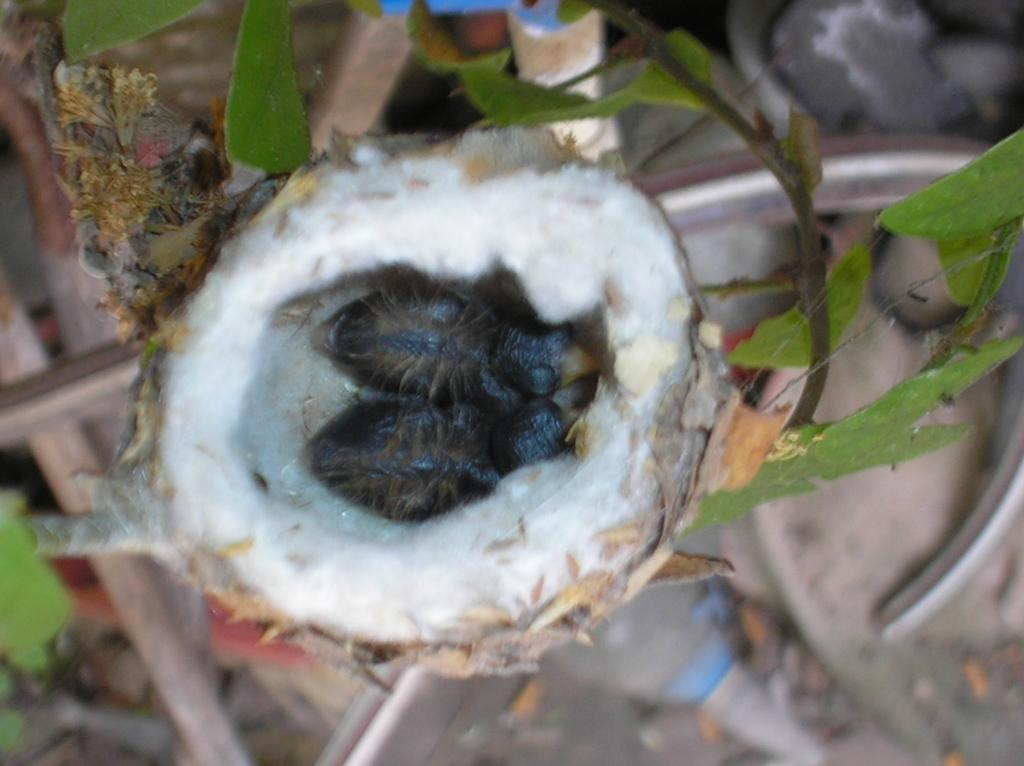How many birds can be seen in the image? There are two birds in the image. Where are the birds located? The birds are in a nest. What type of vegetation is visible in the image? There are leaves visible in the image. Can you describe the background of the image? The background of the image is blurred. What type of key is used to unlock the earth in the image? There is no key or earth present in the image; it features two birds in a nest with leaves and a blurred background. Can you tell me how many baseballs are visible in the image? There are no baseballs present in the image. 